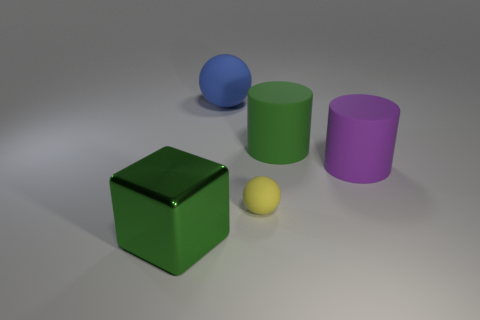Add 1 green matte cylinders. How many objects exist? 6 Subtract all spheres. How many objects are left? 3 Subtract all red balls. How many yellow cylinders are left? 0 Subtract all purple rubber cylinders. Subtract all big matte cylinders. How many objects are left? 2 Add 1 large blue objects. How many large blue objects are left? 2 Add 1 green balls. How many green balls exist? 1 Subtract 1 green cylinders. How many objects are left? 4 Subtract 2 cylinders. How many cylinders are left? 0 Subtract all cyan spheres. Subtract all brown blocks. How many spheres are left? 2 